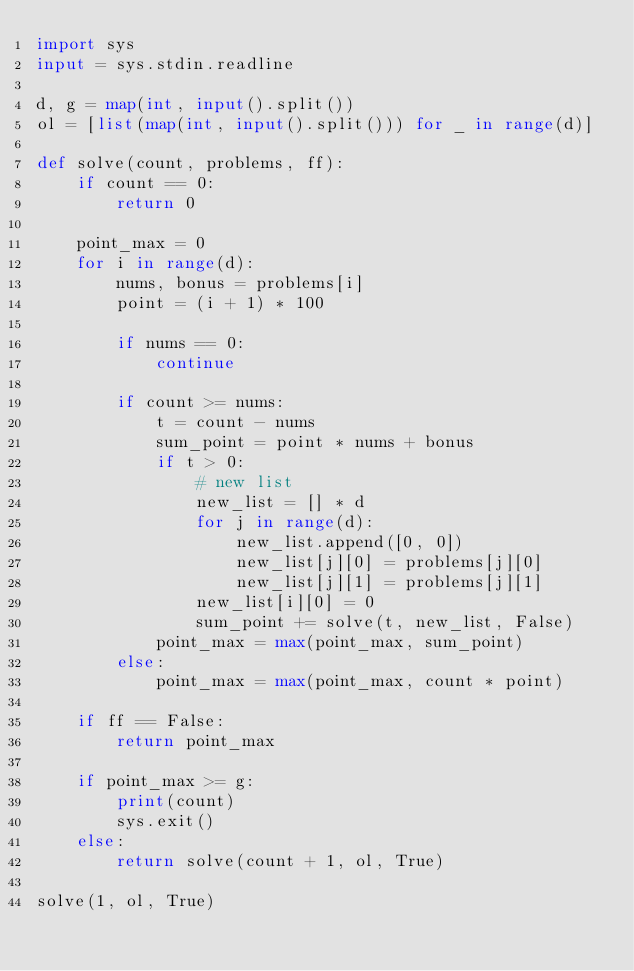<code> <loc_0><loc_0><loc_500><loc_500><_Python_>import sys
input = sys.stdin.readline

d, g = map(int, input().split())
ol = [list(map(int, input().split())) for _ in range(d)]

def solve(count, problems, ff):
    if count == 0:
        return 0
    
    point_max = 0
    for i in range(d):
        nums, bonus = problems[i]
        point = (i + 1) * 100
        
        if nums == 0:
            continue
        
        if count >= nums:
            t = count - nums
            sum_point = point * nums + bonus
            if t > 0:
                # new list
                new_list = [] * d
                for j in range(d):
                    new_list.append([0, 0])
                    new_list[j][0] = problems[j][0]
                    new_list[j][1] = problems[j][1]
                new_list[i][0] = 0
                sum_point += solve(t, new_list, False)
            point_max = max(point_max, sum_point)
        else:
            point_max = max(point_max, count * point) 
            
    if ff == False:
        return point_max
            
    if point_max >= g:
        print(count)
        sys.exit()
    else:
        return solve(count + 1, ol, True)

solve(1, ol, True)</code> 